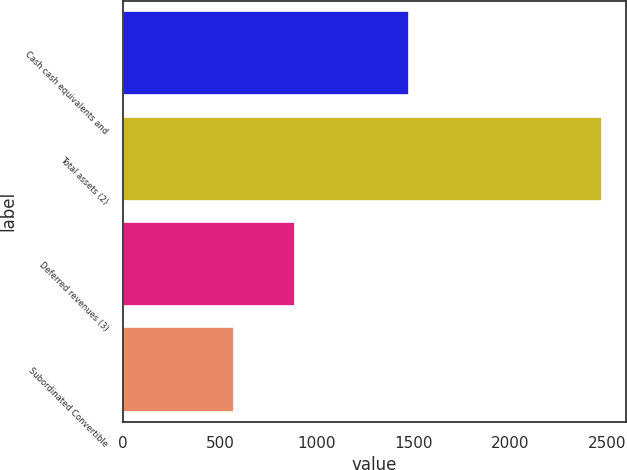<chart> <loc_0><loc_0><loc_500><loc_500><bar_chart><fcel>Cash cash equivalents and<fcel>Total assets (2)<fcel>Deferred revenues (3)<fcel>Subordinated Convertible<nl><fcel>1477<fcel>2470<fcel>888<fcel>574<nl></chart> 